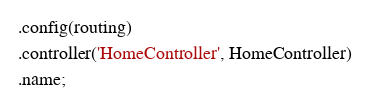Convert code to text. <code><loc_0><loc_0><loc_500><loc_500><_JavaScript_> .config(routing)
 .controller('HomeController', HomeController)
 .name;
</code> 